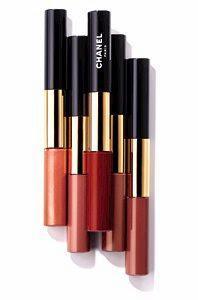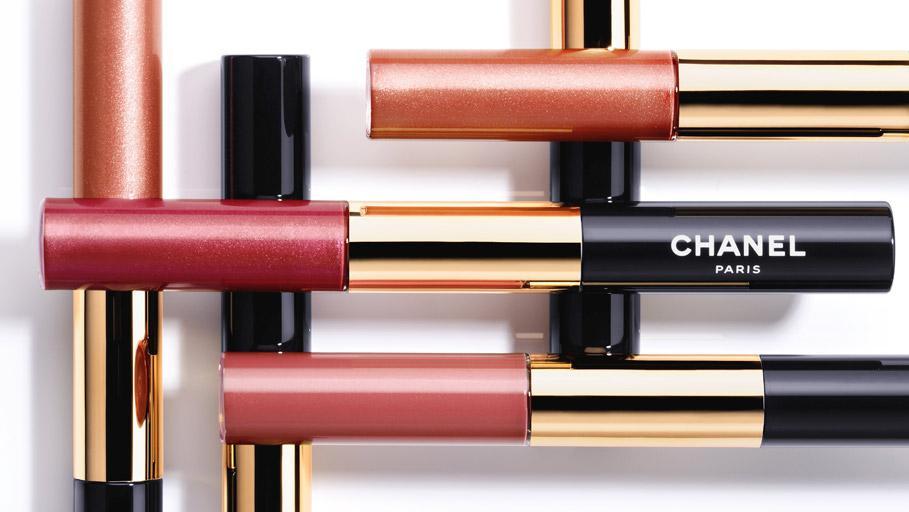The first image is the image on the left, the second image is the image on the right. Examine the images to the left and right. Is the description "There are at most 2 lipsticks in the image pair" accurate? Answer yes or no. No. The first image is the image on the left, the second image is the image on the right. Assess this claim about the two images: "All of the lipsticks shown are arranged parallel to one another, both within and across the two images.". Correct or not? Answer yes or no. No. 